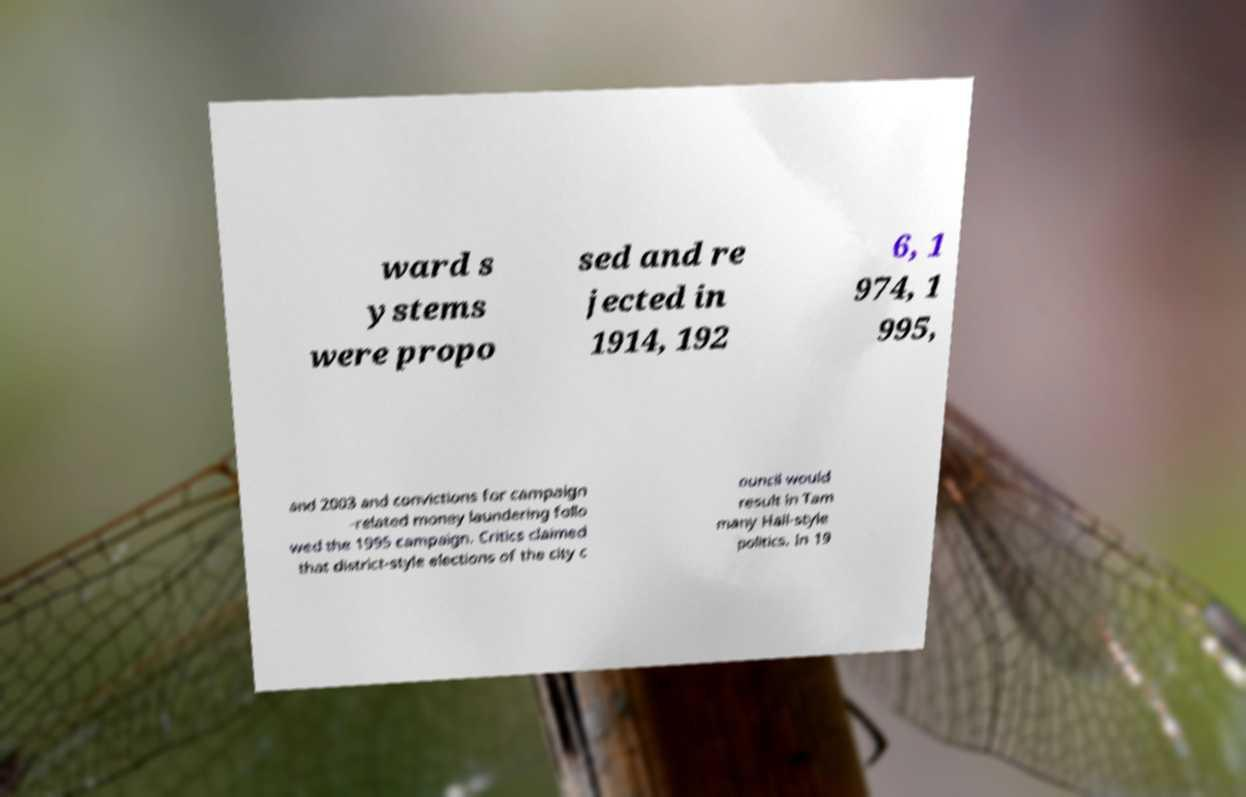Please read and relay the text visible in this image. What does it say? ward s ystems were propo sed and re jected in 1914, 192 6, 1 974, 1 995, and 2003 and convictions for campaign -related money laundering follo wed the 1995 campaign. Critics claimed that district-style elections of the city c ouncil would result in Tam many Hall-style politics. In 19 